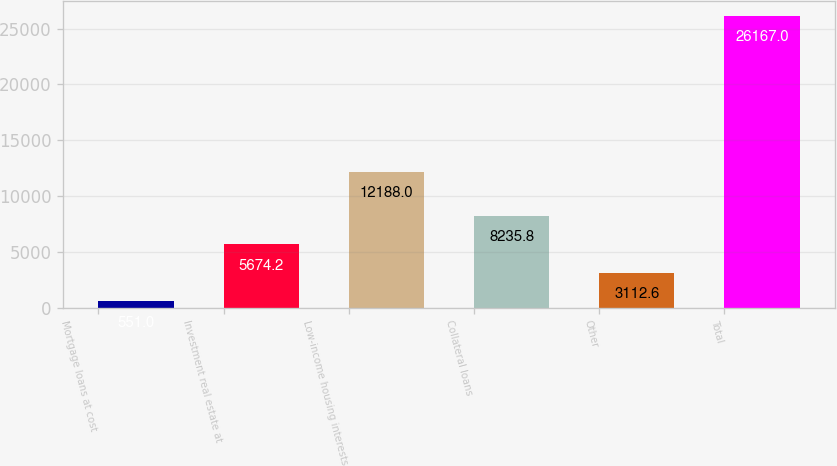Convert chart. <chart><loc_0><loc_0><loc_500><loc_500><bar_chart><fcel>Mortgage loans at cost<fcel>Investment real estate at<fcel>Low-income housing interests<fcel>Collateral loans<fcel>Other<fcel>Total<nl><fcel>551<fcel>5674.2<fcel>12188<fcel>8235.8<fcel>3112.6<fcel>26167<nl></chart> 